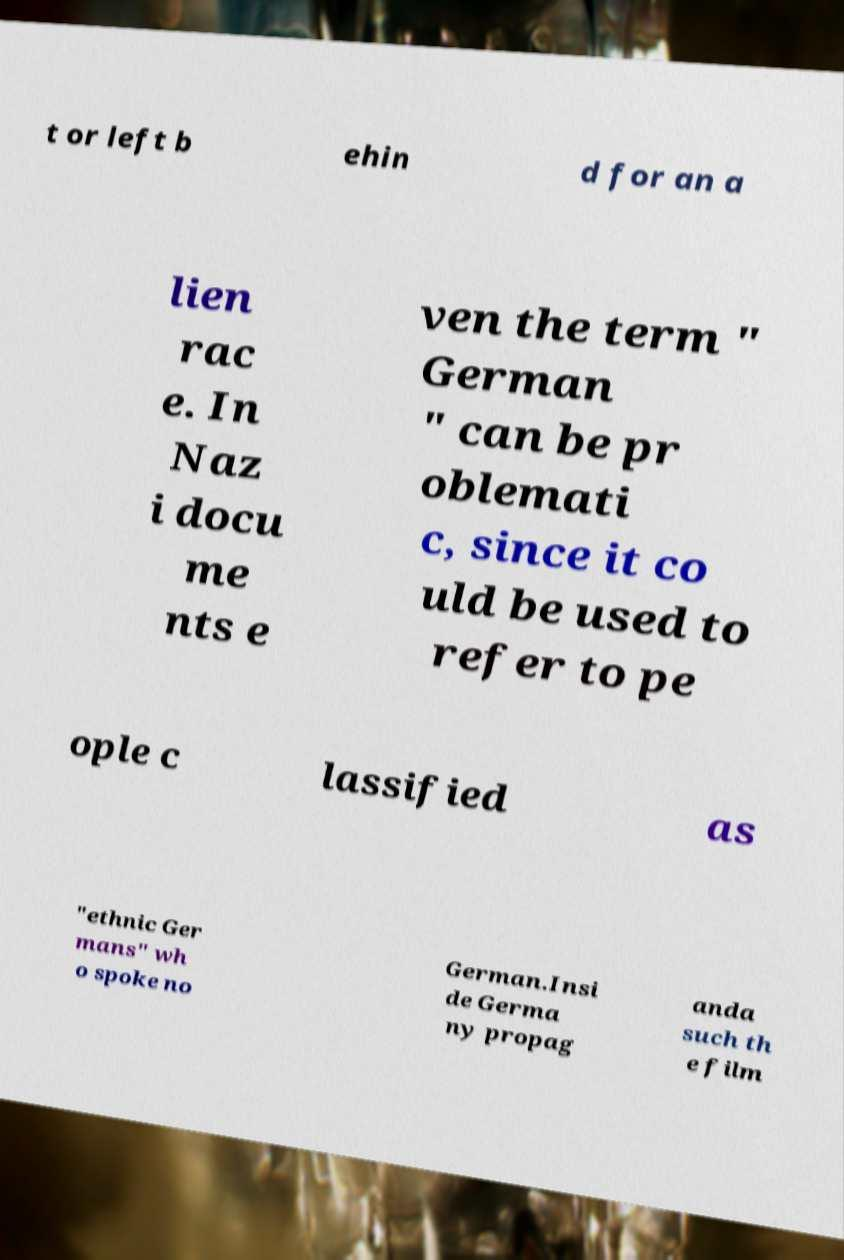I need the written content from this picture converted into text. Can you do that? t or left b ehin d for an a lien rac e. In Naz i docu me nts e ven the term " German " can be pr oblemati c, since it co uld be used to refer to pe ople c lassified as "ethnic Ger mans" wh o spoke no German.Insi de Germa ny propag anda such th e film 